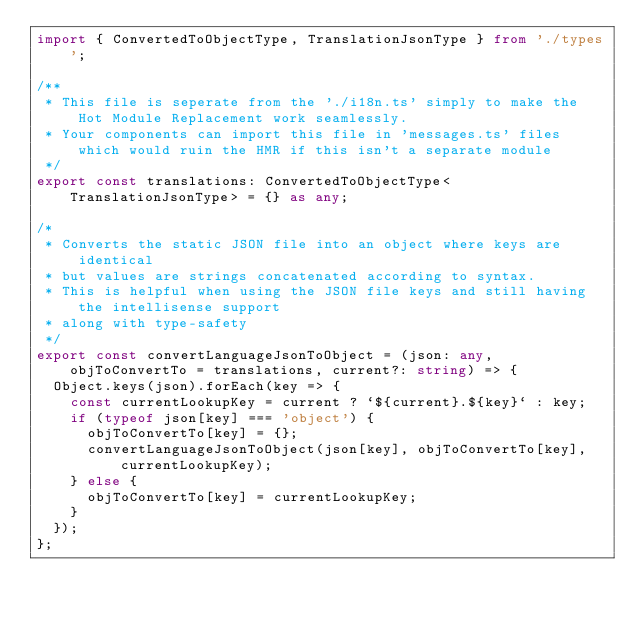<code> <loc_0><loc_0><loc_500><loc_500><_TypeScript_>import { ConvertedToObjectType, TranslationJsonType } from './types';

/**
 * This file is seperate from the './i18n.ts' simply to make the Hot Module Replacement work seamlessly.
 * Your components can import this file in 'messages.ts' files which would ruin the HMR if this isn't a separate module
 */
export const translations: ConvertedToObjectType<TranslationJsonType> = {} as any;

/*
 * Converts the static JSON file into an object where keys are identical
 * but values are strings concatenated according to syntax.
 * This is helpful when using the JSON file keys and still having the intellisense support
 * along with type-safety
 */
export const convertLanguageJsonToObject = (json: any, objToConvertTo = translations, current?: string) => {
  Object.keys(json).forEach(key => {
    const currentLookupKey = current ? `${current}.${key}` : key;
    if (typeof json[key] === 'object') {
      objToConvertTo[key] = {};
      convertLanguageJsonToObject(json[key], objToConvertTo[key], currentLookupKey);
    } else {
      objToConvertTo[key] = currentLookupKey;
    }
  });
};
</code> 